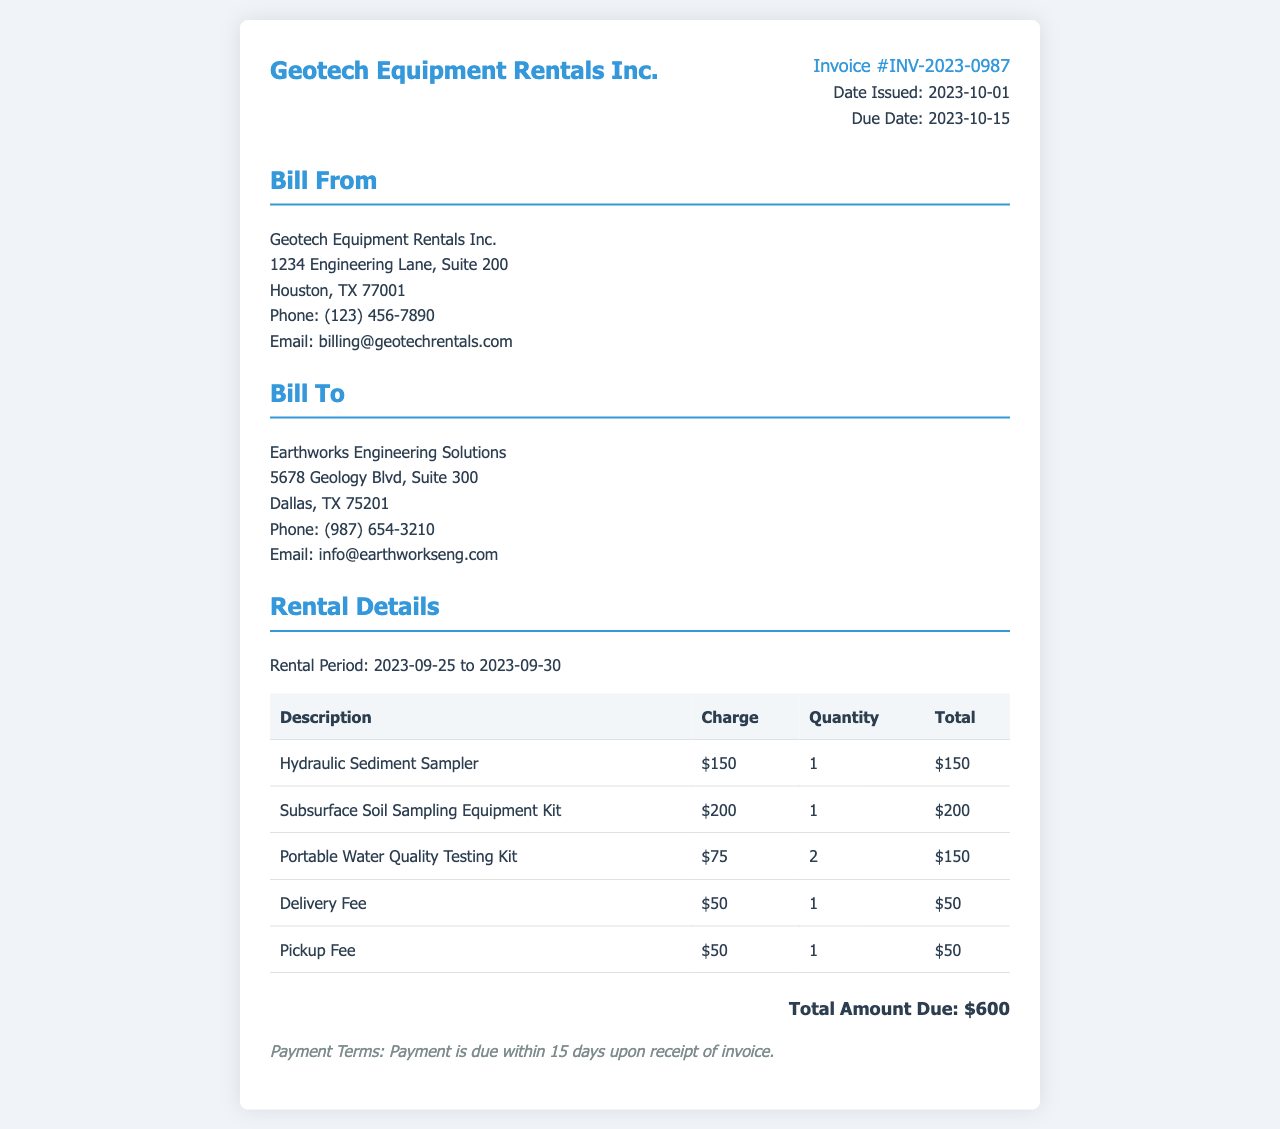what is the invoice number? The invoice number is explicitly stated in the document for easy identification.
Answer: INV-2023-0987 who is the billing address for? The billing address includes the name of the company being billed, which is essential for record-keeping.
Answer: Earthworks Engineering Solutions what is the total amount due? The total amount due is calculated by summing all the charges listed within the invoice.
Answer: $600 what date was the invoice issued? The date when the invoice was officially created is listed, which is important for payment tracking.
Answer: 2023-10-01 how many hydraulic sediment samplers were rented? The quantity of a specific item rented can be critical for inventory and billing purposes.
Answer: 1 what was the rental period? The dates for which the equipment was rented are outlined in the document, important for understanding usage.
Answer: 2023-09-25 to 2023-09-30 what item had the highest individual charge? Identifying the highest charge helps clarify which equipment contributed most to the total.
Answer: Subsurface Soil Sampling Equipment Kit when is the payment due date? The due date for payment is specified to ensure timely transactions and avoid late fees.
Answer: 2023-10-15 